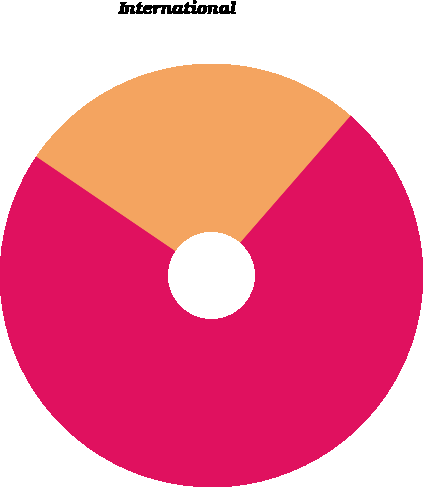Convert chart to OTSL. <chart><loc_0><loc_0><loc_500><loc_500><pie_chart><fcel>United States<fcel>International<nl><fcel>73.1%<fcel>26.9%<nl></chart> 